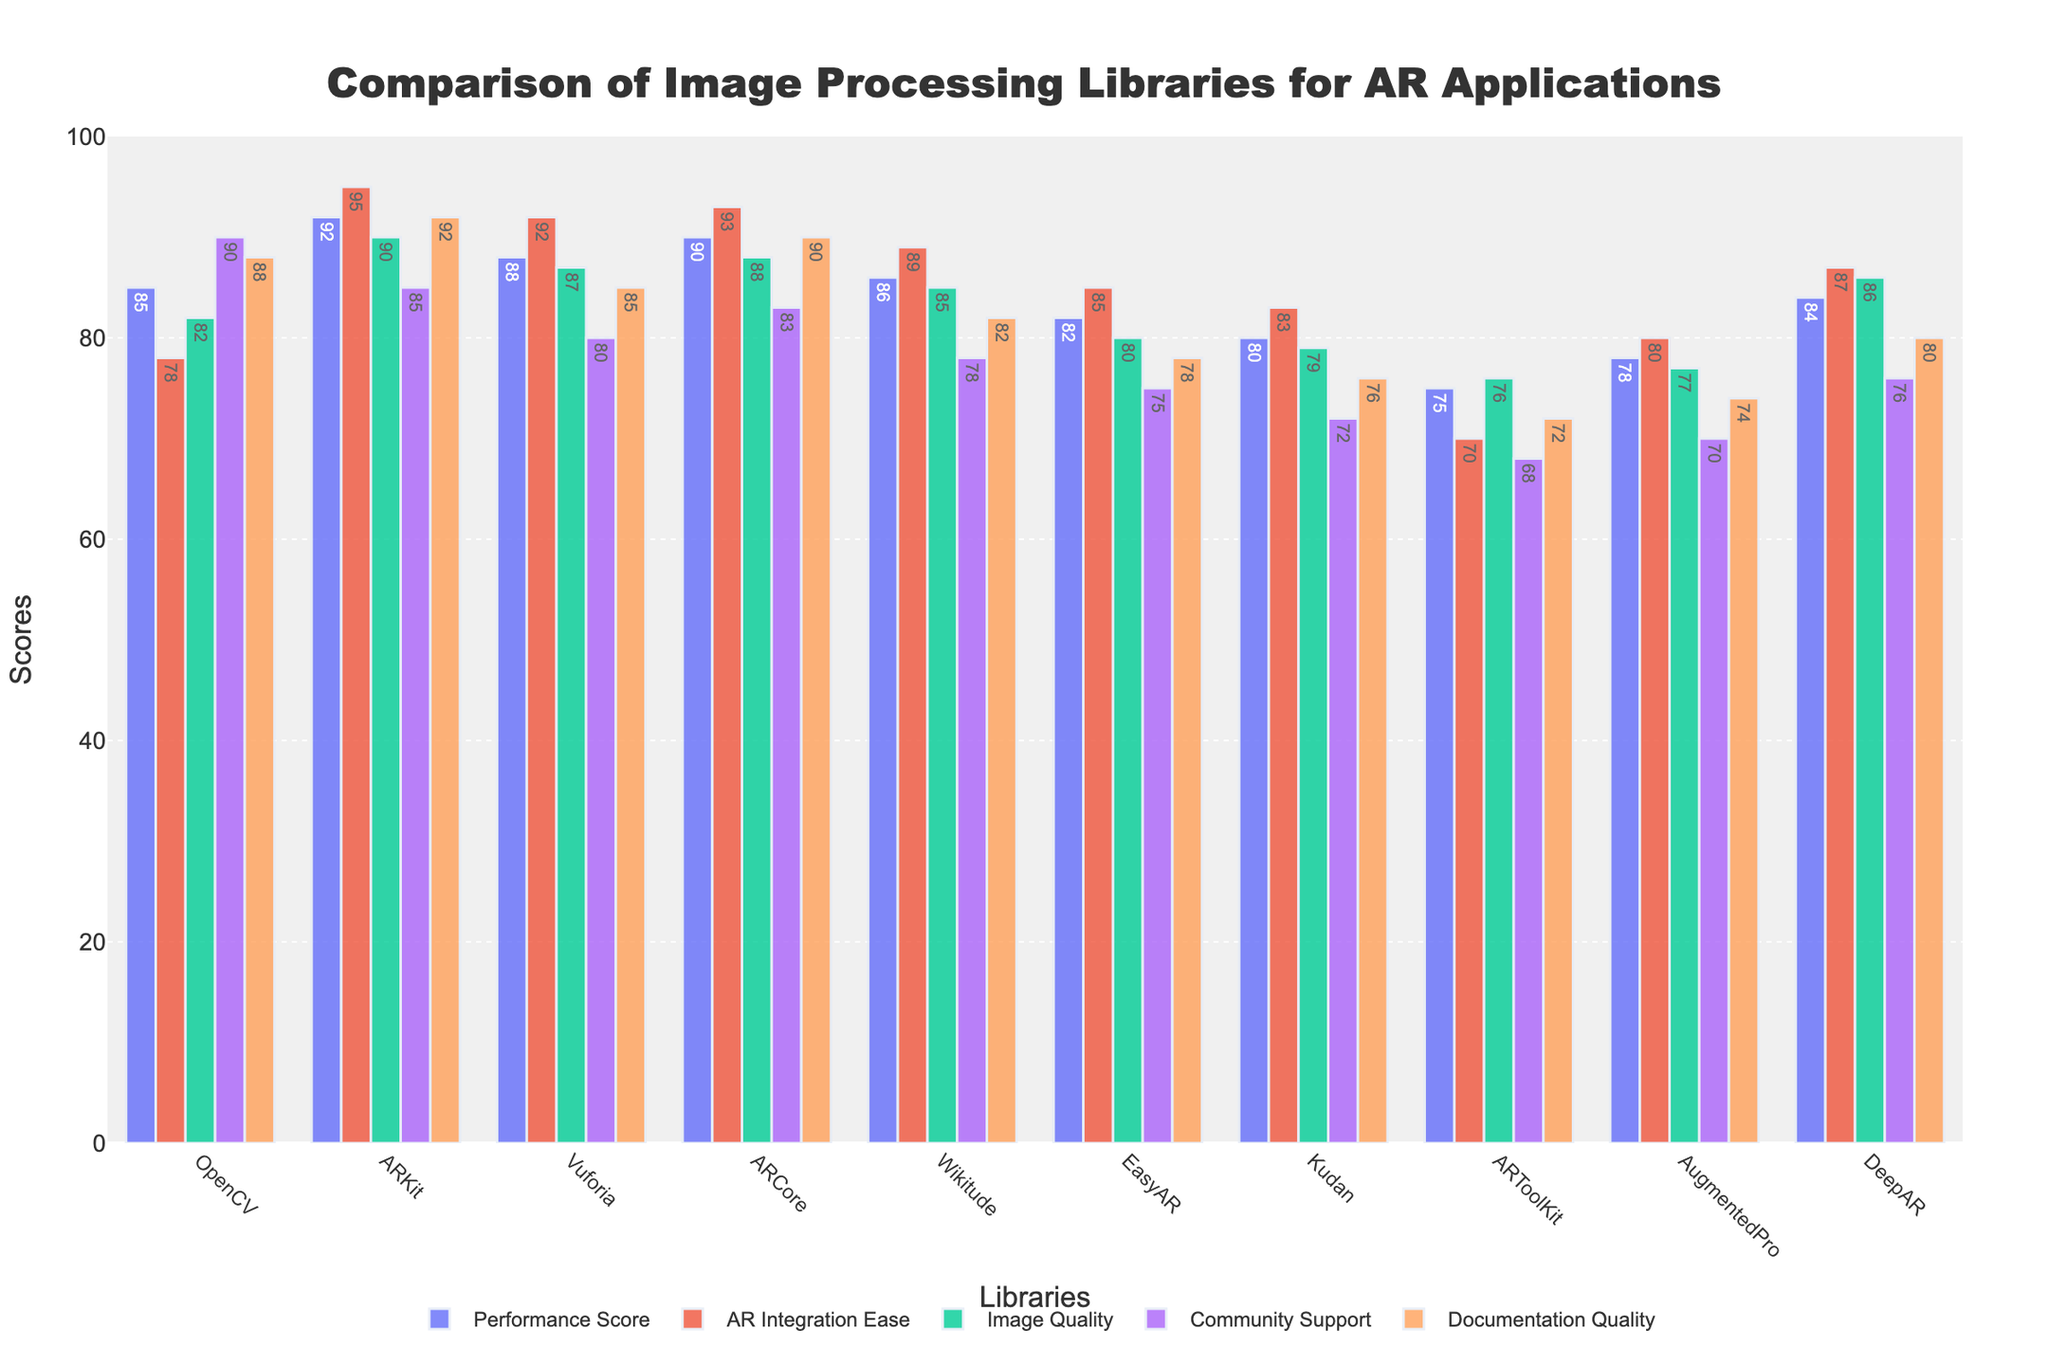Which library has the highest AR Integration Ease score? By examining the heights of the bars labeled "AR Integration Ease," we see that the tallest bar belongs to ARKit.
Answer: ARKit What is the difference in Community Support scores between OpenCV and Vuforia? Locate the bars for "Community Support" on the chart for both OpenCV and Vuforia. OpenCV has a score of 90, and Vuforia has 80. Subtract 80 from 90.
Answer: 10 Which library has the lowest score for Documentation Quality? Identify the shortest bar labeled "Documentation Quality" in the chart. ARToolKit has the shortest bar with a score of 72.
Answer: ARToolKit What is the average Performance Score of ARCore, ARKit, and Vuforia? The Performance Scores are 90 for ARCore, 92 for ARKit, and 88 for Vuforia. Add these scores: 90 + 92 + 88 = 270. Divide by 3: 270 / 3.
Answer: 90 Do ARKit and ARCore have equal Image Quality scores? Compare the heights of the "Image Quality" bars for ARKit and ARCore. Both bars are the same height with a score of 90.
Answer: Yes Which library has a higher Documentation Quality score: Wikitude or Kudan? Compare the heights of the bars labeled "Documentation Quality" for Wikitude and Kudan. Wikitude has a score of 82, while Kudan has a score of 76.
Answer: Wikitude What is the sum of the AR Integration Ease score and Image Quality score for EasyAR? EasyAR has an AR Integration Ease score of 85 and an Image Quality score of 80. Add the two scores together: 85 + 80.
Answer: 165 What is the median Community Support score across all libraries? List and sort the Community Support scores: [68, 70, 72, 75, 76, 78, 80, 83, 85, 87, 90]. The median is the middle value when sorted, which in this case is 80.
Answer: 80 Which library has the highest variance in scores across all categories? Calculate the variance for each library’s scores. Variance measures the spread of numbers. After calculations, note that ARToolKit has the widest spread: (75-70-76-68-72).
Answer: ARToolKit 